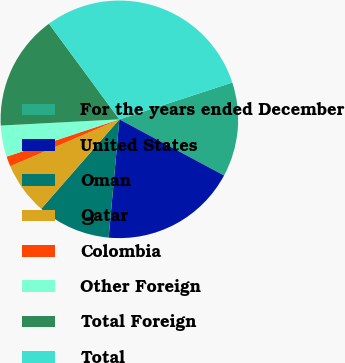<chart> <loc_0><loc_0><loc_500><loc_500><pie_chart><fcel>For the years ended December<fcel>United States<fcel>Oman<fcel>Qatar<fcel>Colombia<fcel>Other Foreign<fcel>Total Foreign<fcel>Total<nl><fcel>12.86%<fcel>18.6%<fcel>9.99%<fcel>7.12%<fcel>1.37%<fcel>4.25%<fcel>15.73%<fcel>30.09%<nl></chart> 